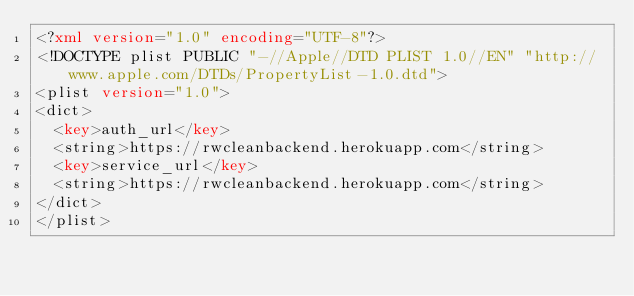<code> <loc_0><loc_0><loc_500><loc_500><_XML_><?xml version="1.0" encoding="UTF-8"?>
<!DOCTYPE plist PUBLIC "-//Apple//DTD PLIST 1.0//EN" "http://www.apple.com/DTDs/PropertyList-1.0.dtd">
<plist version="1.0">
<dict>
	<key>auth_url</key>
	<string>https://rwcleanbackend.herokuapp.com</string>
	<key>service_url</key>
	<string>https://rwcleanbackend.herokuapp.com</string>
</dict>
</plist>
</code> 